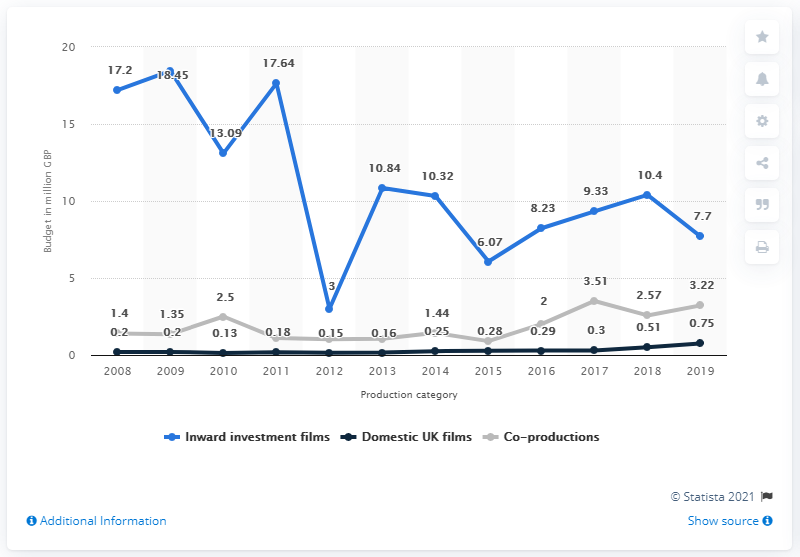Give some essential details in this illustration. In 2019, the median budget for inward investment features was £7.7 million. The median budget for inward investment features in 2012 was 7.7. 